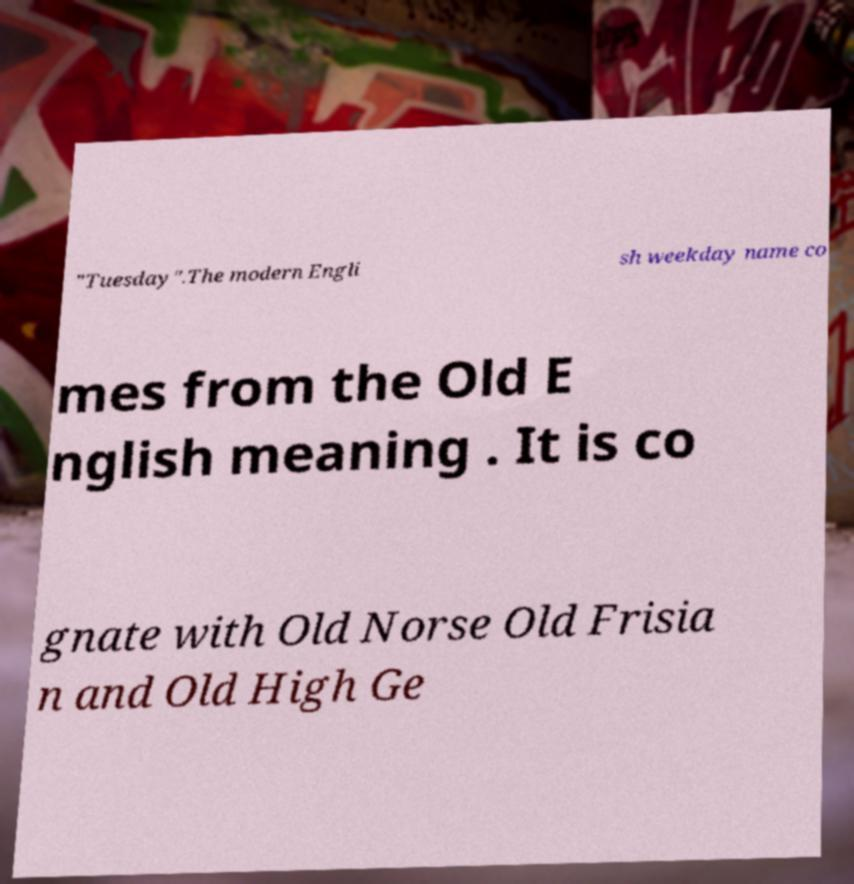Could you extract and type out the text from this image? "Tuesday".The modern Engli sh weekday name co mes from the Old E nglish meaning . It is co gnate with Old Norse Old Frisia n and Old High Ge 